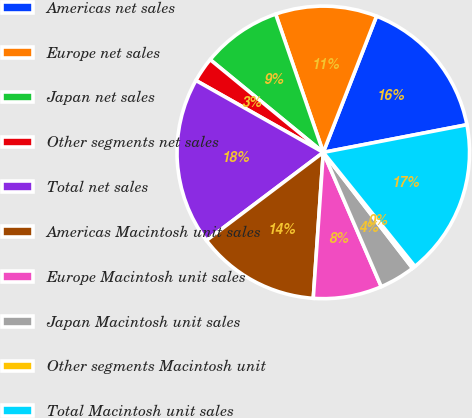Convert chart to OTSL. <chart><loc_0><loc_0><loc_500><loc_500><pie_chart><fcel>Americas net sales<fcel>Europe net sales<fcel>Japan net sales<fcel>Other segments net sales<fcel>Total net sales<fcel>Americas Macintosh unit sales<fcel>Europe Macintosh unit sales<fcel>Japan Macintosh unit sales<fcel>Other segments Macintosh unit<fcel>Total Macintosh unit sales<nl><fcel>16.04%<fcel>11.21%<fcel>8.79%<fcel>2.75%<fcel>18.46%<fcel>13.63%<fcel>7.58%<fcel>3.96%<fcel>0.33%<fcel>17.25%<nl></chart> 